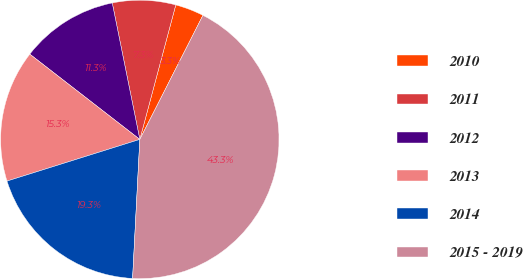Convert chart to OTSL. <chart><loc_0><loc_0><loc_500><loc_500><pie_chart><fcel>2010<fcel>2011<fcel>2012<fcel>2013<fcel>2014<fcel>2015 - 2019<nl><fcel>3.33%<fcel>7.33%<fcel>11.33%<fcel>15.33%<fcel>19.33%<fcel>43.33%<nl></chart> 